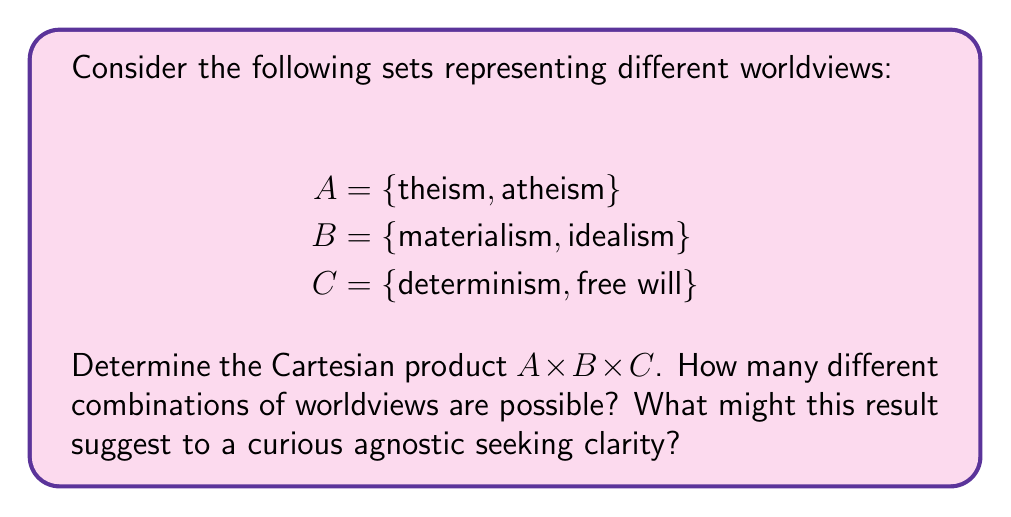Could you help me with this problem? To solve this problem, we need to understand the concept of Cartesian product and apply it to the given sets.

1. The Cartesian product of two sets X and Y, denoted X × Y, is the set of all ordered pairs (x, y) where x ∈ X and y ∈ Y.

2. For three sets, the Cartesian product A × B × C is the set of all ordered triples (a, b, c) where a ∈ A, b ∈ B, and c ∈ C.

3. Let's calculate the Cartesian product A × B × C:

   A × B × C = {(a, b, c) | a ∈ A, b ∈ B, c ∈ C}

4. To find all possible combinations, we need to pair each element from A with each element from B and each element from C:

   {(theism, materialism, determinism), (theism, materialism, free will),
    (theism, idealism, determinism), (theism, idealism, free will),
    (atheism, materialism, determinism), (atheism, materialism, free will),
    (atheism, idealism, determinism), (atheism, idealism, free will)}

5. To count the number of combinations, we can use the multiplication principle:

   $|A × B × C| = |A| \cdot |B| \cdot |C| = 2 \cdot 2 \cdot 2 = 8$

This result suggests that there are 8 possible combinations of worldviews based on the given sets. For a curious agnostic seeking clarity, this demonstrates the complexity of worldviews and how different philosophical positions can be combined. It also highlights that one's worldview is not necessarily a single, monolithic belief but can be a combination of different perspectives on various philosophical questions.
Answer: The Cartesian product A × B × C contains 8 different combinations of worldviews. This is calculated as $|A × B × C| = |A| \cdot |B| \cdot |C| = 2 \cdot 2 \cdot 2 = 8$. 